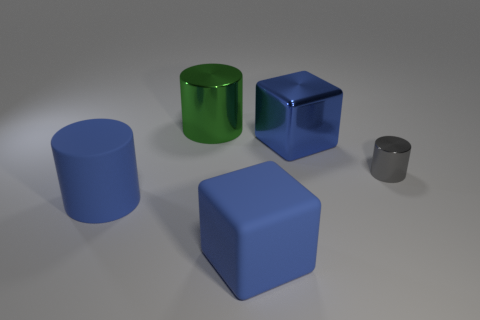There is a big blue rubber block; are there any objects to the left of it?
Provide a short and direct response. Yes. What color is the tiny cylinder?
Your answer should be very brief. Gray. There is a rubber cube; does it have the same color as the big cylinder that is in front of the big metallic cube?
Offer a very short reply. Yes. Is there a matte block that has the same size as the green shiny cylinder?
Offer a terse response. Yes. What is the blue object that is to the left of the large rubber block made of?
Your answer should be compact. Rubber. Is the number of tiny gray things in front of the small metallic cylinder the same as the number of tiny metal objects behind the large blue shiny cube?
Provide a succinct answer. Yes. Does the blue object that is left of the rubber cube have the same size as the metallic cylinder that is in front of the large green thing?
Ensure brevity in your answer.  No. How many big objects are the same color as the rubber block?
Give a very brief answer. 2. There is another cube that is the same color as the matte cube; what material is it?
Your answer should be compact. Metal. Are there more rubber cylinders on the left side of the green metallic thing than purple metallic cylinders?
Ensure brevity in your answer.  Yes. 